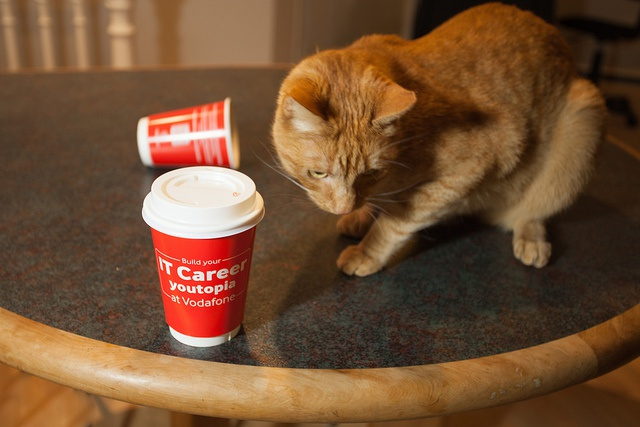Describe the objects in this image and their specific colors. I can see dining table in gray, maroon, black, and tan tones, cat in gray, brown, maroon, and black tones, cup in gray, white, red, and maroon tones, chair in gray, brown, and tan tones, and cup in gray, lightgray, salmon, and red tones in this image. 